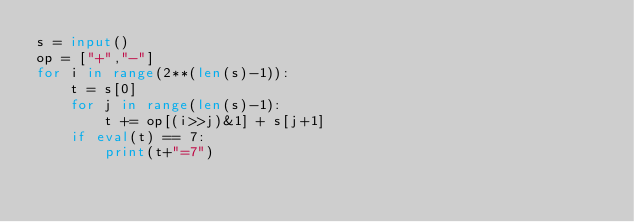<code> <loc_0><loc_0><loc_500><loc_500><_Python_>s = input()
op = ["+","-"]
for i in range(2**(len(s)-1)):
    t = s[0]
    for j in range(len(s)-1):
        t += op[(i>>j)&1] + s[j+1]
    if eval(t) == 7:
        print(t+"=7")</code> 